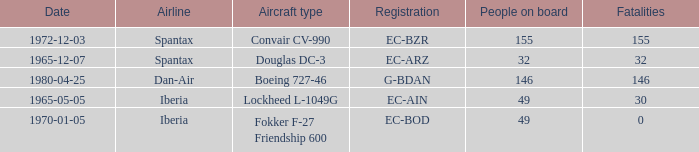What is the number of people on board at Iberia Airline, with the aircraft type of lockheed l-1049g? 49.0. 